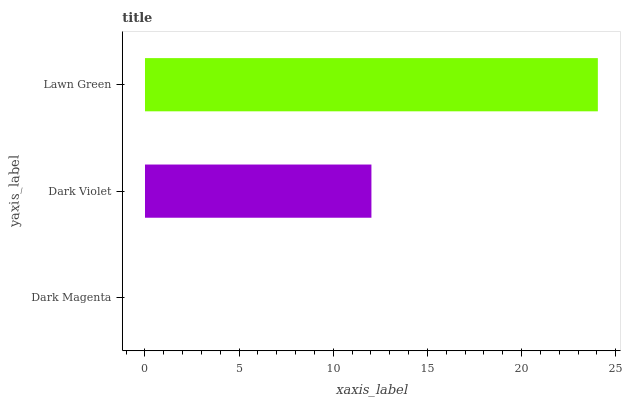Is Dark Magenta the minimum?
Answer yes or no. Yes. Is Lawn Green the maximum?
Answer yes or no. Yes. Is Dark Violet the minimum?
Answer yes or no. No. Is Dark Violet the maximum?
Answer yes or no. No. Is Dark Violet greater than Dark Magenta?
Answer yes or no. Yes. Is Dark Magenta less than Dark Violet?
Answer yes or no. Yes. Is Dark Magenta greater than Dark Violet?
Answer yes or no. No. Is Dark Violet less than Dark Magenta?
Answer yes or no. No. Is Dark Violet the high median?
Answer yes or no. Yes. Is Dark Violet the low median?
Answer yes or no. Yes. Is Dark Magenta the high median?
Answer yes or no. No. Is Dark Magenta the low median?
Answer yes or no. No. 